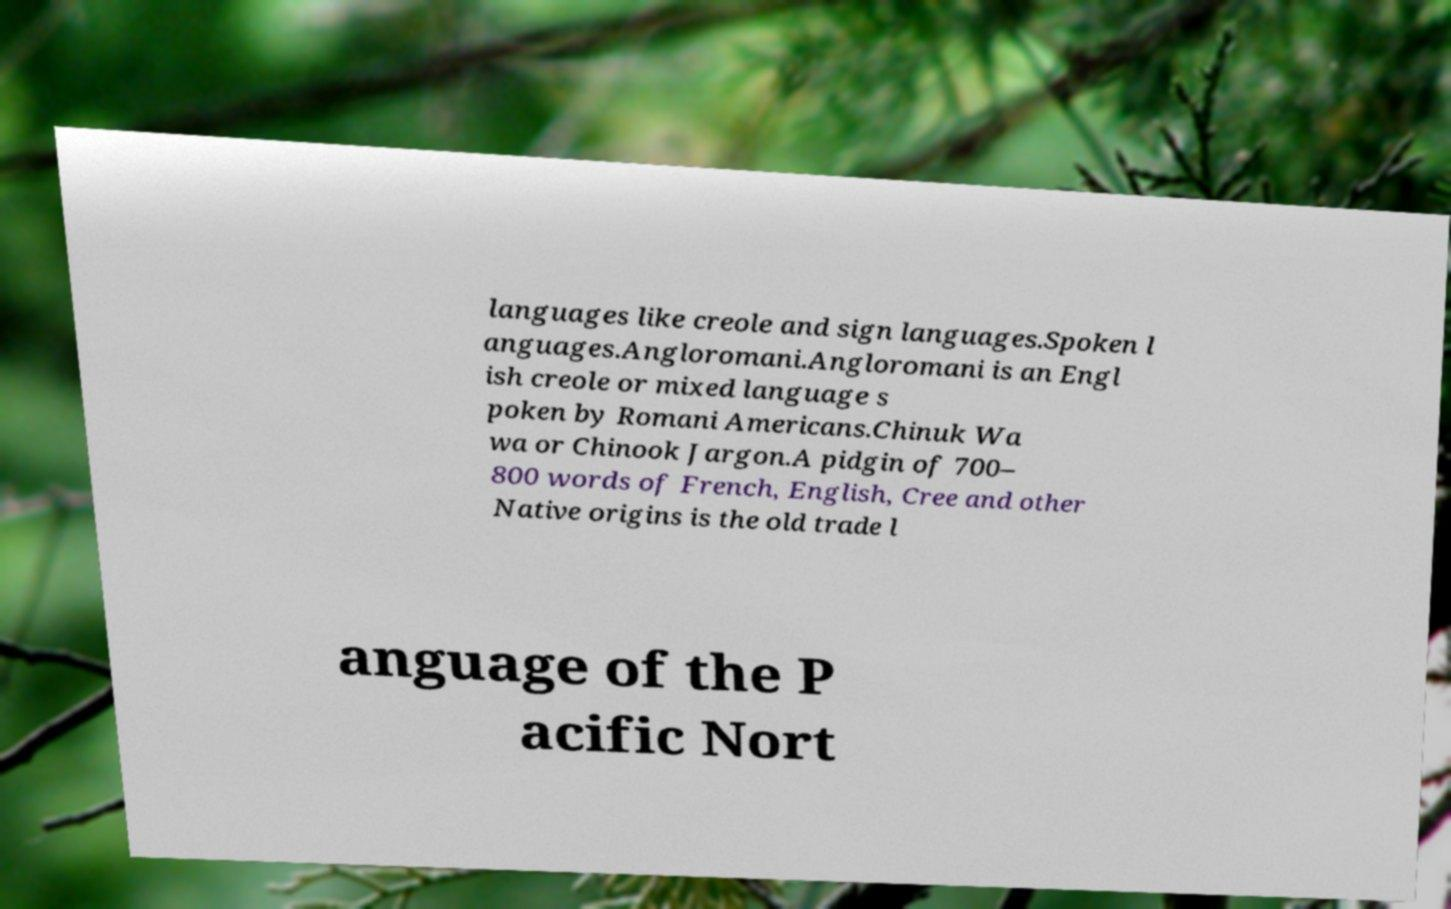There's text embedded in this image that I need extracted. Can you transcribe it verbatim? languages like creole and sign languages.Spoken l anguages.Angloromani.Angloromani is an Engl ish creole or mixed language s poken by Romani Americans.Chinuk Wa wa or Chinook Jargon.A pidgin of 700– 800 words of French, English, Cree and other Native origins is the old trade l anguage of the P acific Nort 